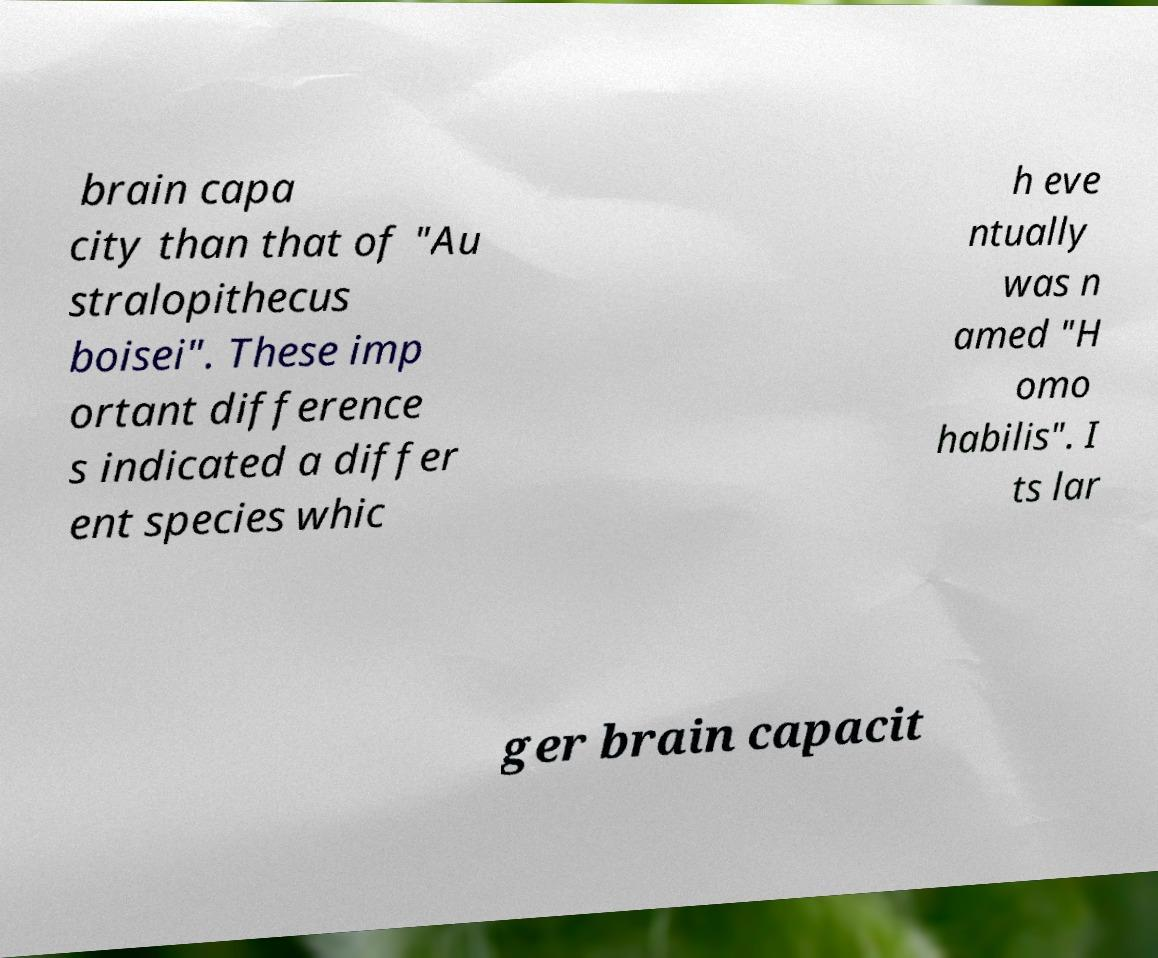Could you extract and type out the text from this image? brain capa city than that of "Au stralopithecus boisei". These imp ortant difference s indicated a differ ent species whic h eve ntually was n amed "H omo habilis". I ts lar ger brain capacit 